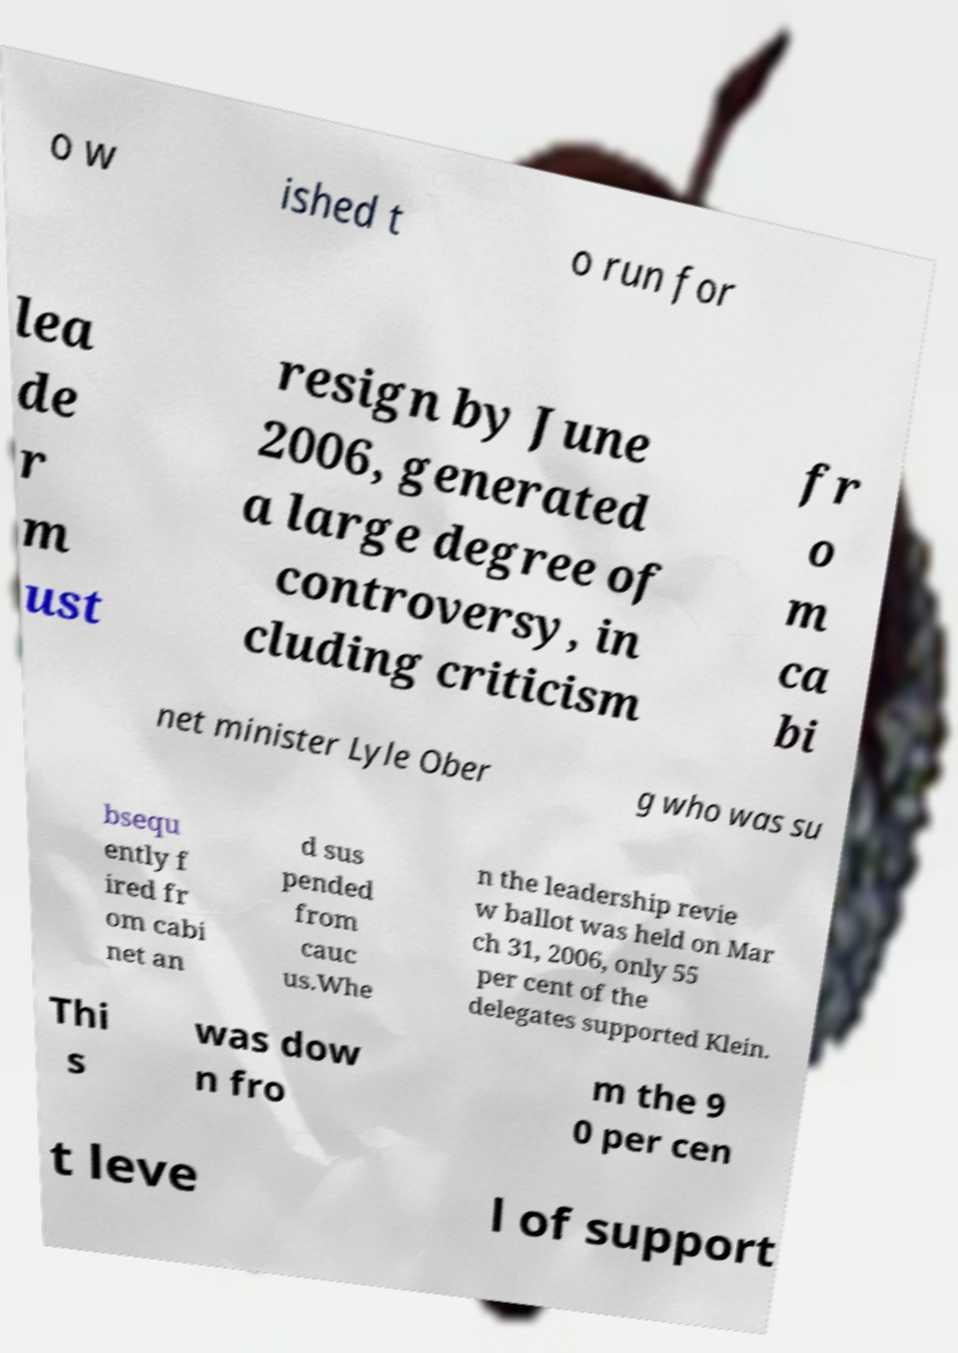Can you read and provide the text displayed in the image?This photo seems to have some interesting text. Can you extract and type it out for me? o w ished t o run for lea de r m ust resign by June 2006, generated a large degree of controversy, in cluding criticism fr o m ca bi net minister Lyle Ober g who was su bsequ ently f ired fr om cabi net an d sus pended from cauc us.Whe n the leadership revie w ballot was held on Mar ch 31, 2006, only 55 per cent of the delegates supported Klein. Thi s was dow n fro m the 9 0 per cen t leve l of support 